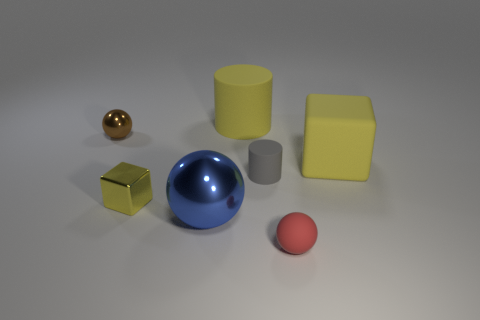Is the large shiny ball the same color as the small matte cylinder?
Provide a short and direct response. No. How many spheres are tiny matte objects or tiny metallic things?
Provide a succinct answer. 2. What is the material of the ball that is both on the right side of the small brown thing and behind the small red matte sphere?
Your answer should be very brief. Metal. What number of spheres are right of the big blue thing?
Give a very brief answer. 1. Is the material of the large yellow thing behind the rubber cube the same as the tiny sphere to the left of the tiny red rubber ball?
Make the answer very short. No. What number of objects are either cubes that are right of the gray rubber cylinder or rubber objects?
Provide a succinct answer. 4. Are there fewer small yellow metal objects that are on the right side of the yellow cylinder than gray matte cylinders that are in front of the tiny gray rubber cylinder?
Ensure brevity in your answer.  No. How many other things are there of the same size as the blue shiny object?
Your answer should be compact. 2. Do the large sphere and the ball that is to the right of the big ball have the same material?
Give a very brief answer. No. How many objects are either rubber objects behind the small rubber sphere or large yellow blocks behind the red thing?
Your answer should be compact. 3. 